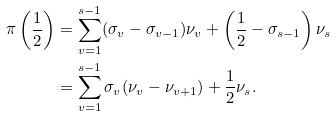<formula> <loc_0><loc_0><loc_500><loc_500>\pi \left ( \frac { 1 } { 2 } \right ) & = \sum _ { v = 1 } ^ { s - 1 } ( \sigma _ { v } - \sigma _ { v - 1 } ) \nu _ { v } + \left ( \frac { 1 } { 2 } - \sigma _ { s - 1 } \right ) \nu _ { s } \\ & = \sum _ { v = 1 } ^ { s - 1 } \sigma _ { v } ( \nu _ { v } - \nu _ { v + 1 } ) + \frac { 1 } { 2 } \nu _ { s } .</formula> 